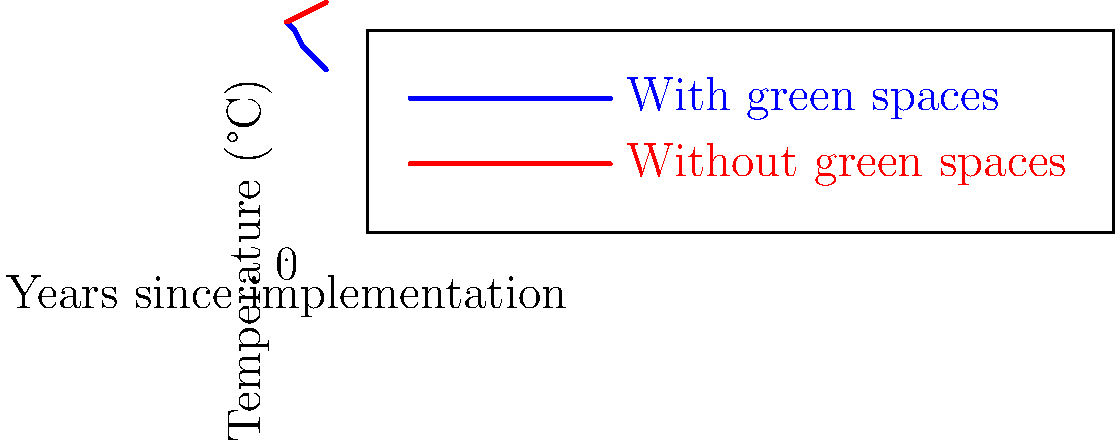Based on the thermal imaging data presented in the graph, which shows temperature trends over 5 years in areas with and without green spaces, what conclusion can be drawn about the effectiveness of green spaces in mitigating urban heat islands? To evaluate the effectiveness of green spaces in reducing urban heat islands using the thermal imaging data, we need to analyze the temperature trends shown in the graph:

1. Identify the two data sets:
   - Blue line: Areas with green spaces
   - Red line: Areas without green spaces

2. Observe the initial temperatures:
   - Both areas start at 30°C in year 0

3. Analyze the temperature trends over 5 years:
   - Areas with green spaces (blue line):
     Temperature decreases from 30°C to 24°C
   - Areas without green spaces (red line):
     Temperature increases from 30°C to 32.5°C

4. Calculate the temperature difference after 5 years:
   - With green spaces: 24°C
   - Without green spaces: 32.5°C
   - Difference: 32.5°C - 24°C = 8.5°C

5. Interpret the results:
   - Areas with green spaces show a consistent cooling trend
   - Areas without green spaces show a consistent warming trend
   - The temperature difference of 8.5°C after 5 years is significant

6. Draw a conclusion:
   The data clearly demonstrates that green spaces are effective in mitigating urban heat islands, as they lead to a substantial temperature reduction compared to areas without green spaces.
Answer: Green spaces effectively mitigate urban heat islands, reducing temperatures by 8.5°C compared to areas without green spaces over 5 years. 